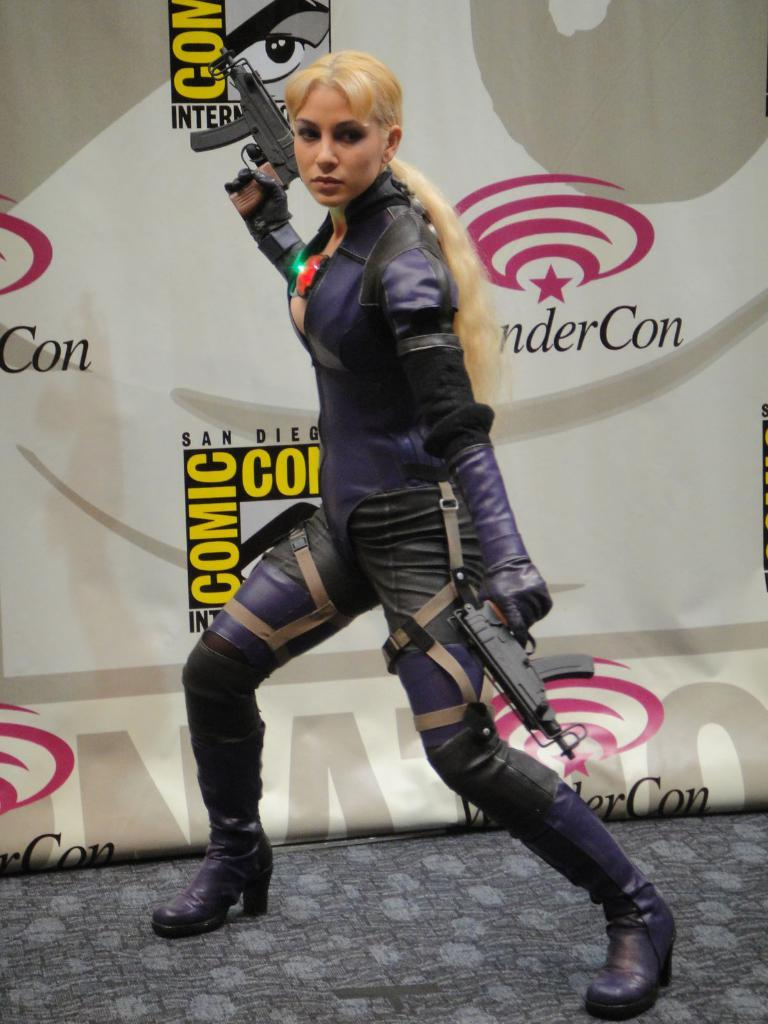Who is the main subject in the image? There is a woman in the image. What is the woman doing in the image? The woman is standing on the floor and holding guns in both hands. What can be seen in the background of the image? There is an advertisement in the background of the image. What type of paper is the woman using to hook the guns in the image? There is no paper or hooking action present in the image; the woman is simply holding the guns in both hands. 